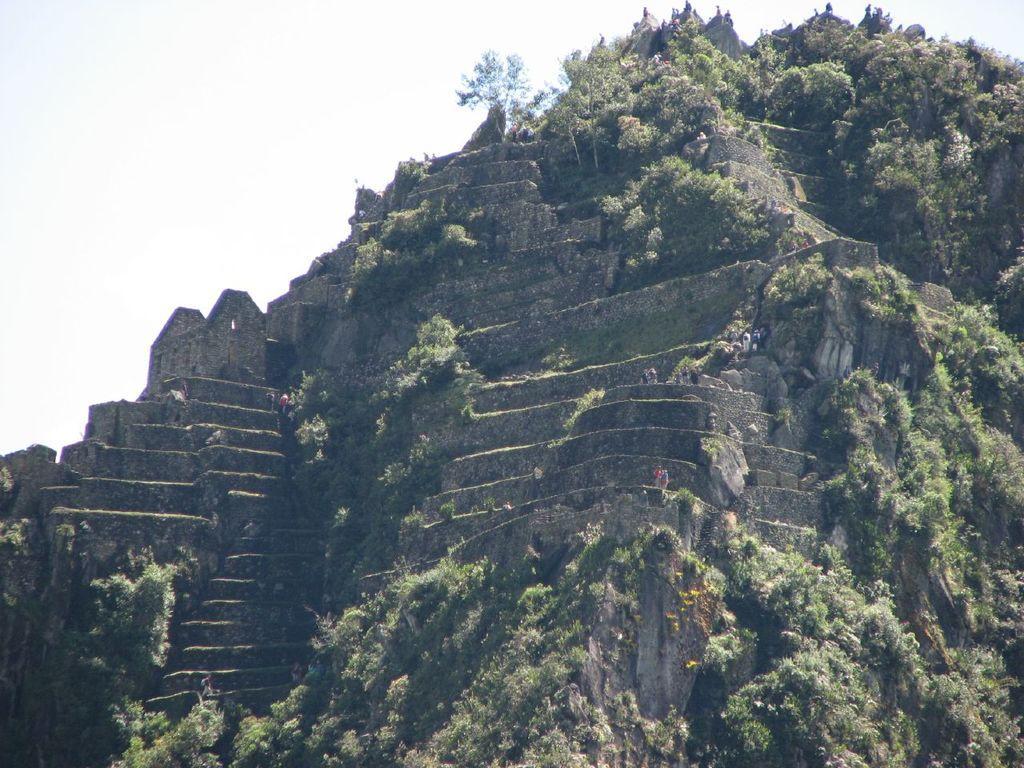In one or two sentences, can you explain what this image depicts? In this picture we can see mountain, trees and people. In the background of the image we can see the sky. 